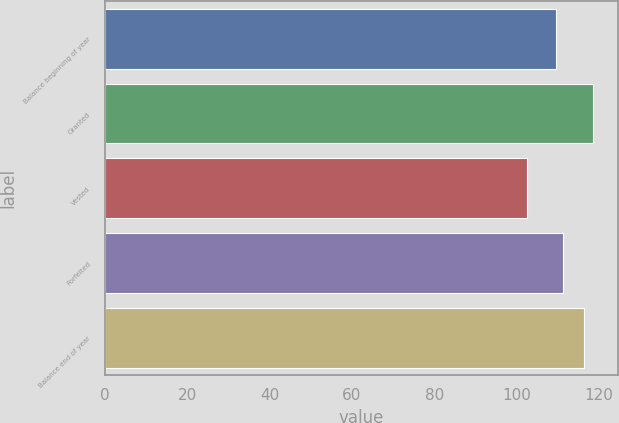Convert chart. <chart><loc_0><loc_0><loc_500><loc_500><bar_chart><fcel>Balance beginning of year<fcel>Granted<fcel>Vested<fcel>Forfeited<fcel>Balance end of year<nl><fcel>109.54<fcel>118.63<fcel>102.4<fcel>111.16<fcel>116.32<nl></chart> 